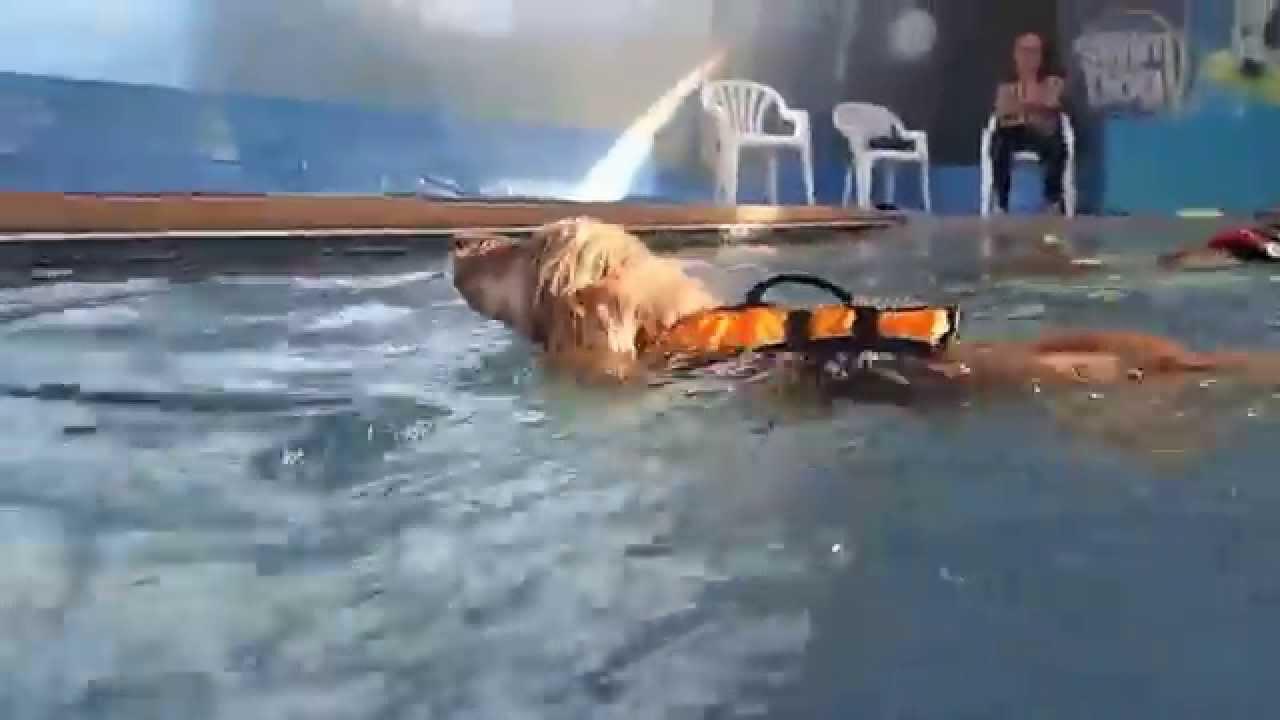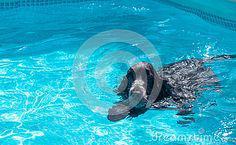The first image is the image on the left, the second image is the image on the right. For the images displayed, is the sentence "A dog is in mid-leap over the blue water of a manmade pool." factually correct? Answer yes or no. No. The first image is the image on the left, the second image is the image on the right. Examine the images to the left and right. Is the description "One of the dogs is using a floatation device in the pool." accurate? Answer yes or no. Yes. 